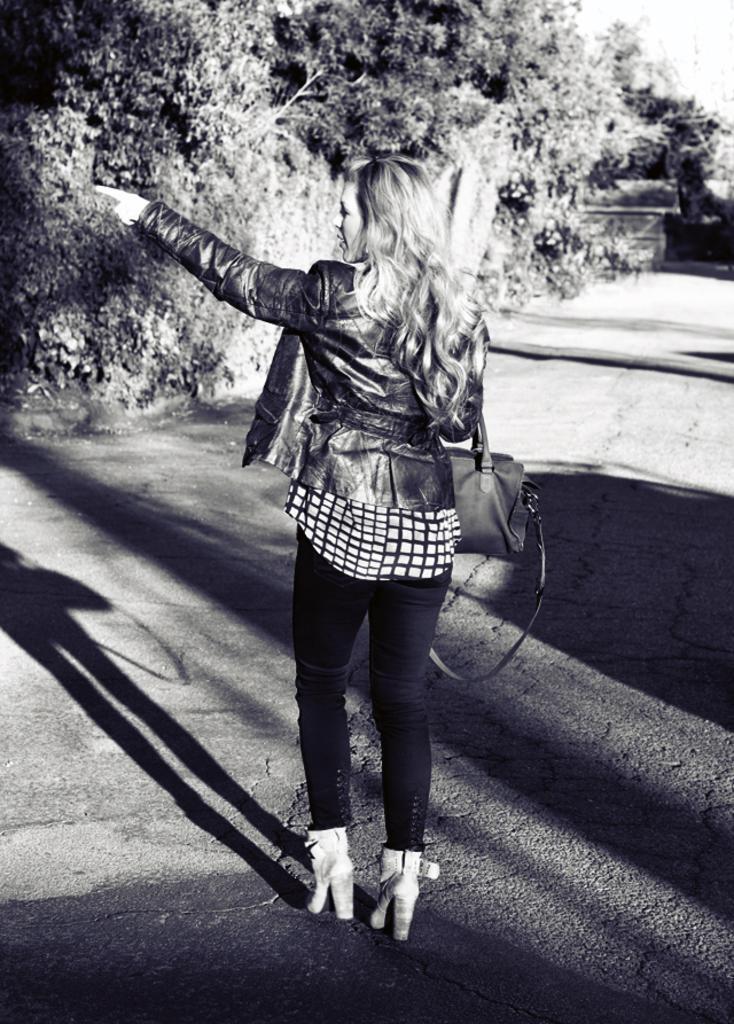Describe this image in one or two sentences. In this picture we can see a woman on the road. She is carrying her bag. On the background we can see some trees and this is the sky. 